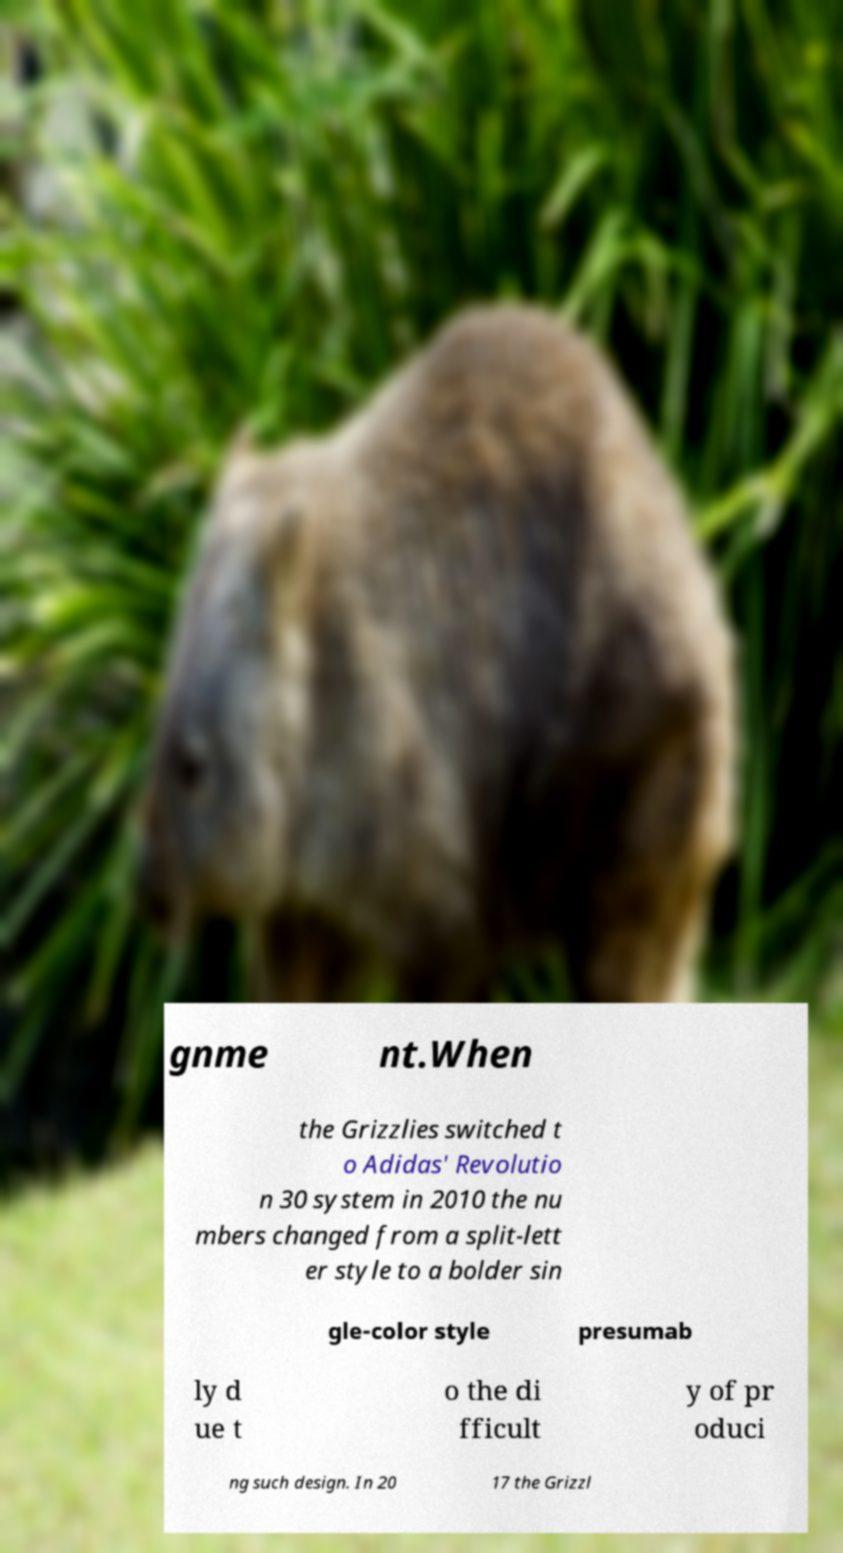Could you extract and type out the text from this image? gnme nt.When the Grizzlies switched t o Adidas' Revolutio n 30 system in 2010 the nu mbers changed from a split-lett er style to a bolder sin gle-color style presumab ly d ue t o the di fficult y of pr oduci ng such design. In 20 17 the Grizzl 